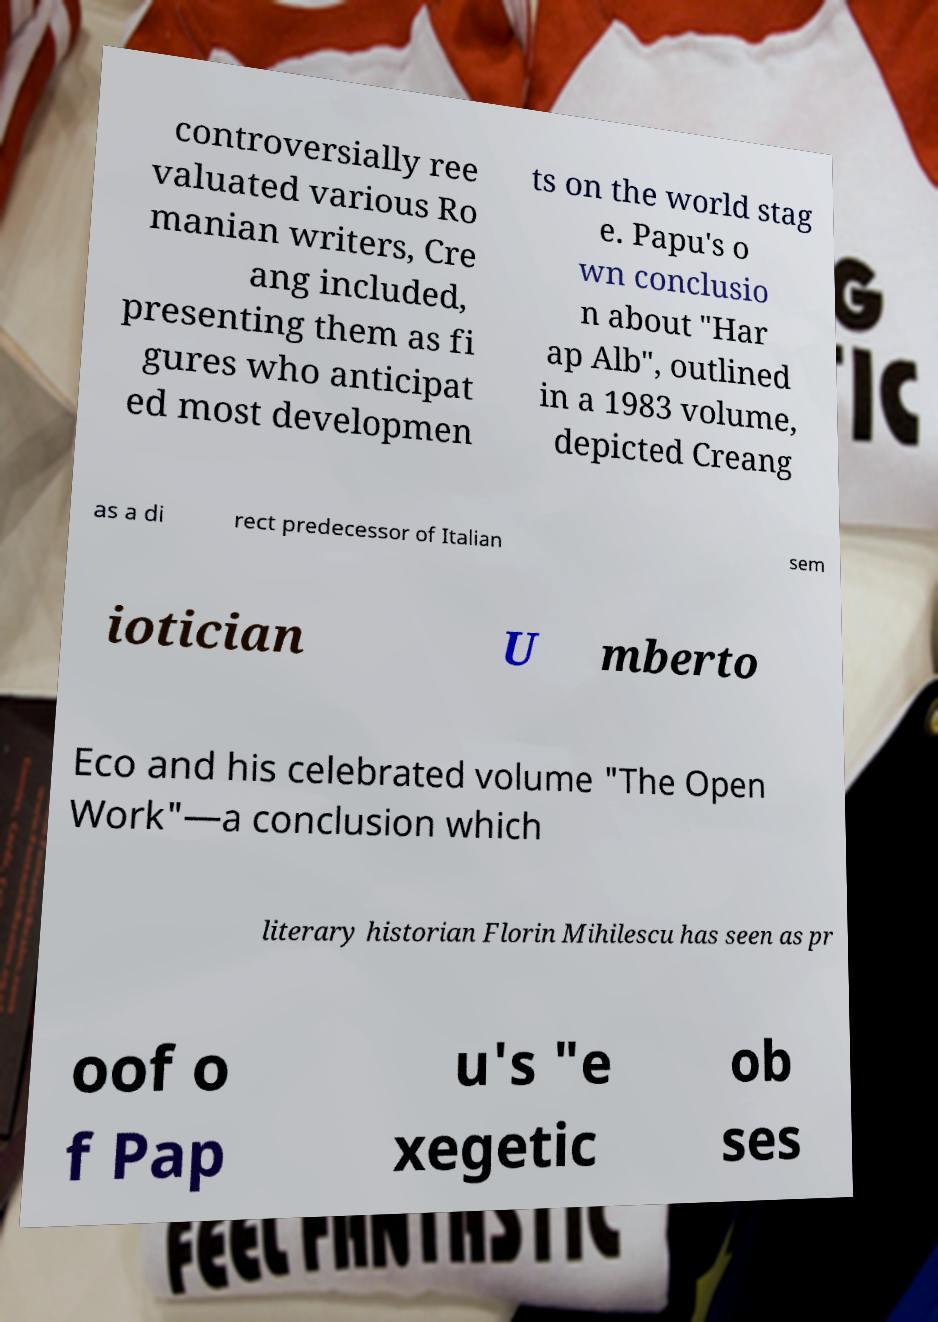I need the written content from this picture converted into text. Can you do that? controversially ree valuated various Ro manian writers, Cre ang included, presenting them as fi gures who anticipat ed most developmen ts on the world stag e. Papu's o wn conclusio n about "Har ap Alb", outlined in a 1983 volume, depicted Creang as a di rect predecessor of Italian sem iotician U mberto Eco and his celebrated volume "The Open Work"—a conclusion which literary historian Florin Mihilescu has seen as pr oof o f Pap u's "e xegetic ob ses 